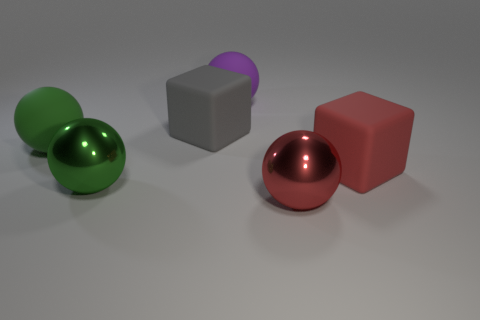Subtract all brown balls. Subtract all purple cylinders. How many balls are left? 4 Add 2 large green metal objects. How many objects exist? 8 Subtract all balls. How many objects are left? 2 Subtract 1 red spheres. How many objects are left? 5 Subtract all big rubber spheres. Subtract all purple rubber balls. How many objects are left? 3 Add 5 red balls. How many red balls are left? 6 Add 1 large green shiny things. How many large green shiny things exist? 2 